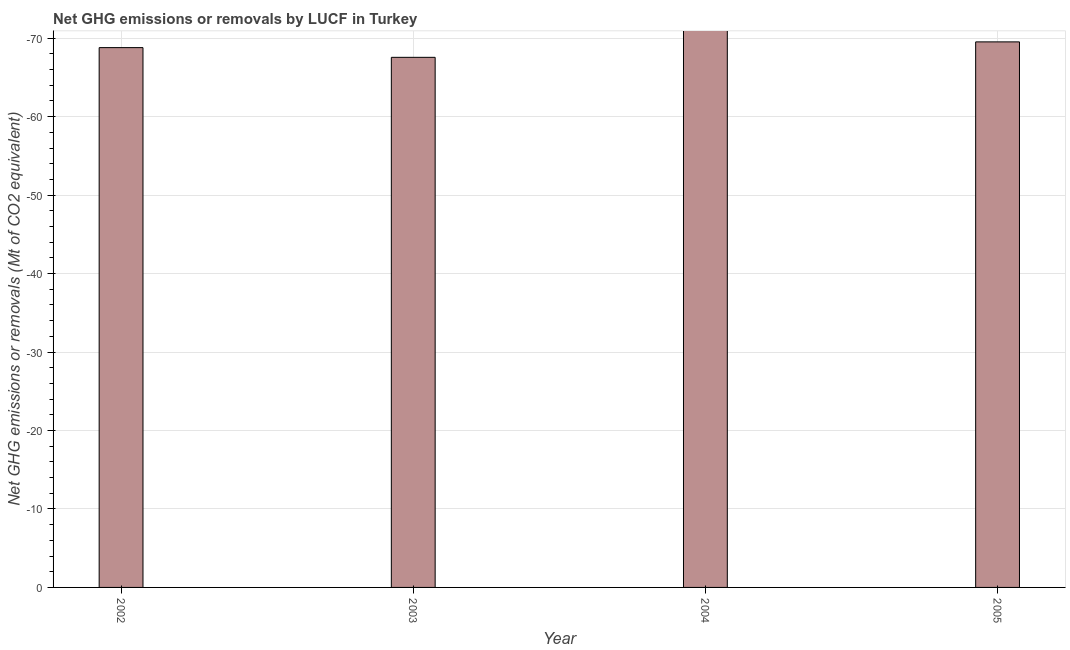What is the title of the graph?
Your response must be concise. Net GHG emissions or removals by LUCF in Turkey. What is the label or title of the X-axis?
Make the answer very short. Year. What is the label or title of the Y-axis?
Your answer should be very brief. Net GHG emissions or removals (Mt of CO2 equivalent). What is the ghg net emissions or removals in 2005?
Ensure brevity in your answer.  0. What is the sum of the ghg net emissions or removals?
Keep it short and to the point. 0. What is the average ghg net emissions or removals per year?
Make the answer very short. 0. In how many years, is the ghg net emissions or removals greater than -34 Mt?
Your answer should be very brief. 0. How many bars are there?
Provide a succinct answer. 0. What is the Net GHG emissions or removals (Mt of CO2 equivalent) in 2005?
Your response must be concise. 0. 